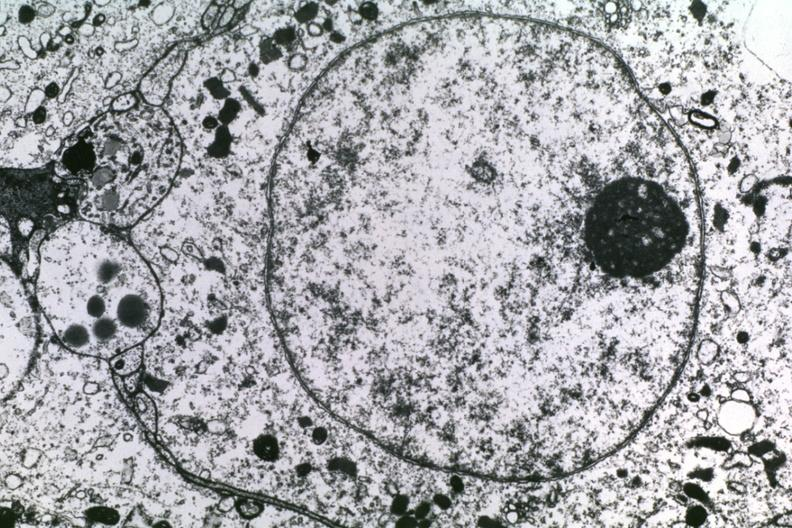what does this image show?
Answer the question using a single word or phrase. Dr garcia tumors 55 